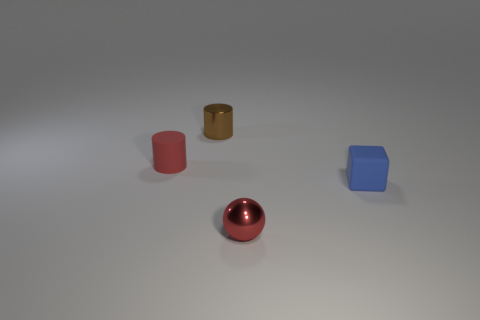Add 3 tiny matte cylinders. How many objects exist? 7 Subtract all spheres. How many objects are left? 3 Add 3 small red spheres. How many small red spheres are left? 4 Add 1 large red blocks. How many large red blocks exist? 1 Subtract 0 cyan cubes. How many objects are left? 4 Subtract all tiny green metal balls. Subtract all red metallic spheres. How many objects are left? 3 